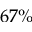<formula> <loc_0><loc_0><loc_500><loc_500>6 7 \%</formula> 